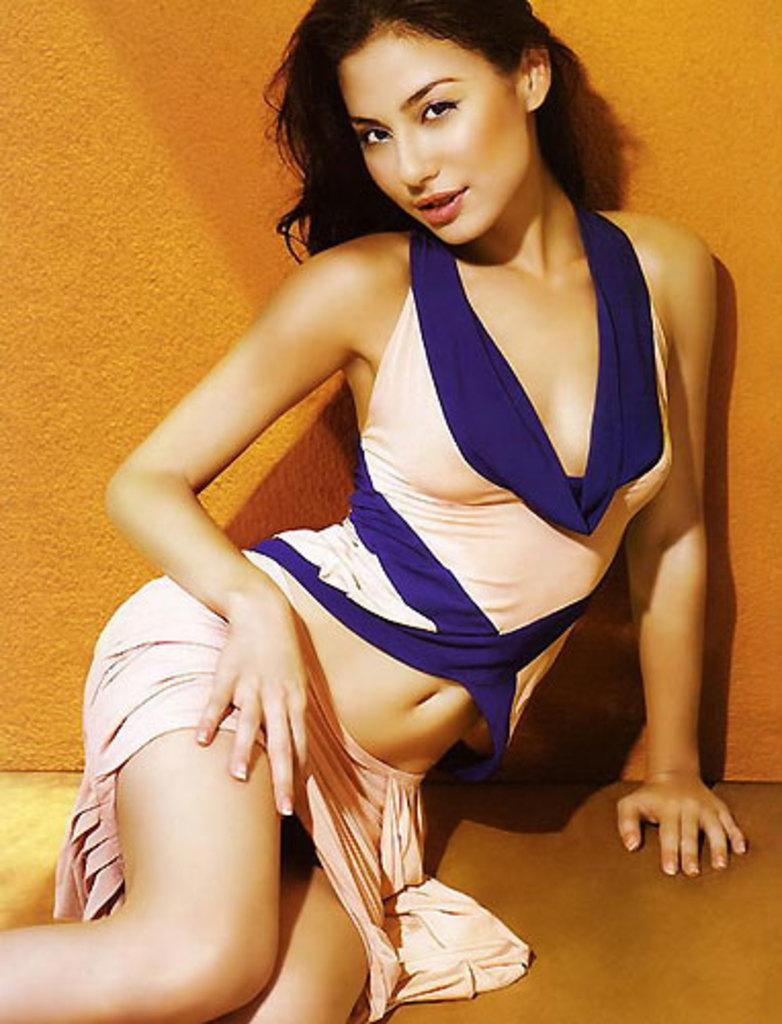What is the woman in the image doing? The woman is sitting in the image. What can be seen behind the woman? There is a wall in the background of the image. What surface is the woman sitting on? There is a floor visible in the image. Is the woman driving a car in the image? No, the woman is sitting, and there is no car or driving activity depicted in the image. 